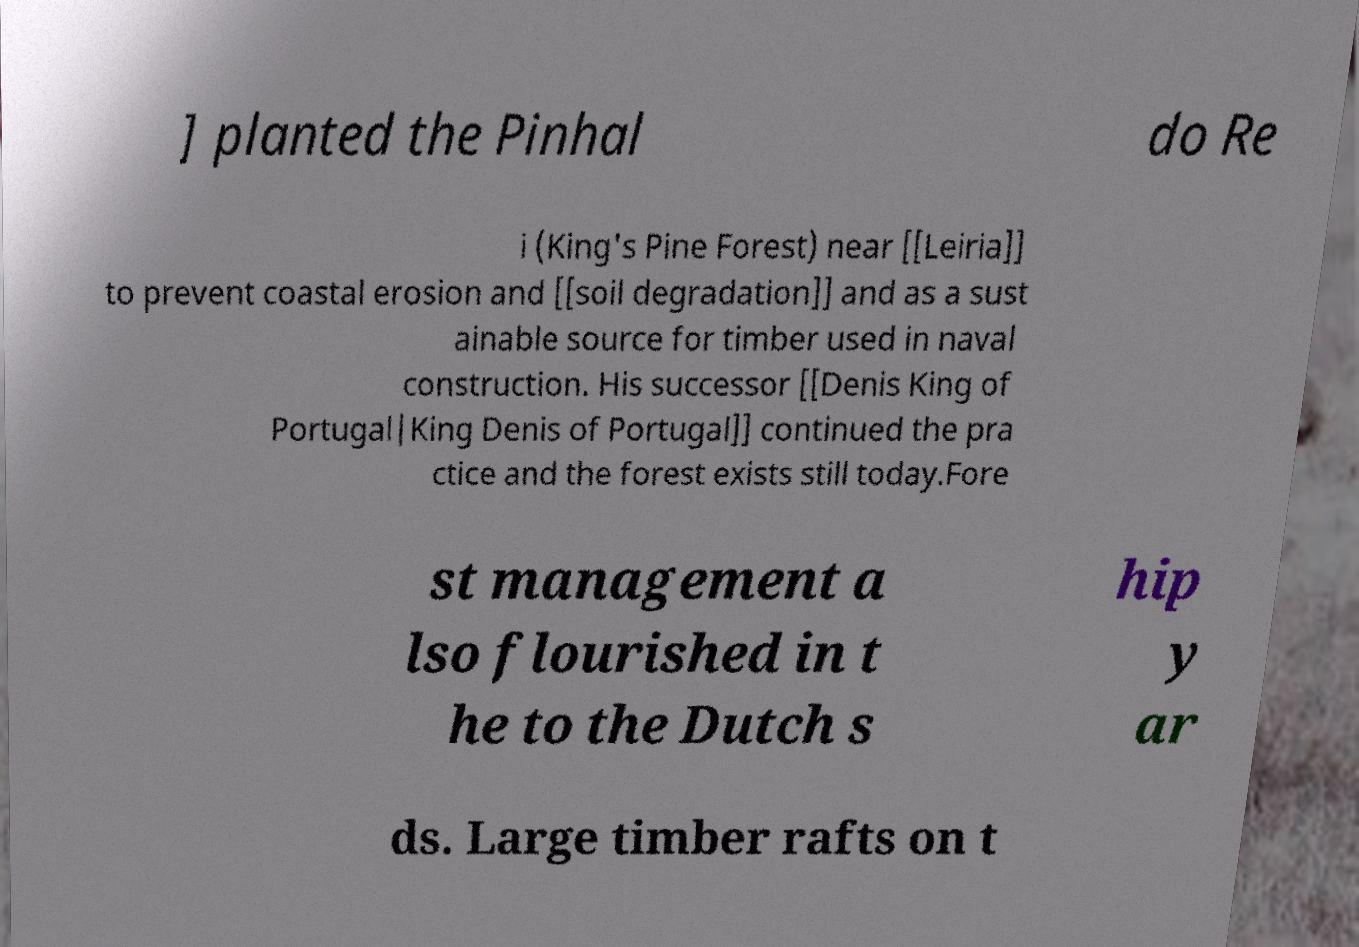What messages or text are displayed in this image? I need them in a readable, typed format. ] planted the Pinhal do Re i (King's Pine Forest) near [[Leiria]] to prevent coastal erosion and [[soil degradation]] and as a sust ainable source for timber used in naval construction. His successor [[Denis King of Portugal|King Denis of Portugal]] continued the pra ctice and the forest exists still today.Fore st management a lso flourished in t he to the Dutch s hip y ar ds. Large timber rafts on t 